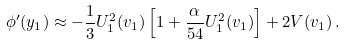<formula> <loc_0><loc_0><loc_500><loc_500>\phi ^ { \prime } ( y _ { 1 } ) \approx - \frac { 1 } { 3 } U _ { 1 } ^ { 2 } ( v _ { 1 } ) \left [ 1 + \frac { \alpha } { 5 4 } U _ { 1 } ^ { 2 } ( v _ { 1 } ) \right ] + 2 V ( v _ { 1 } ) \, .</formula> 